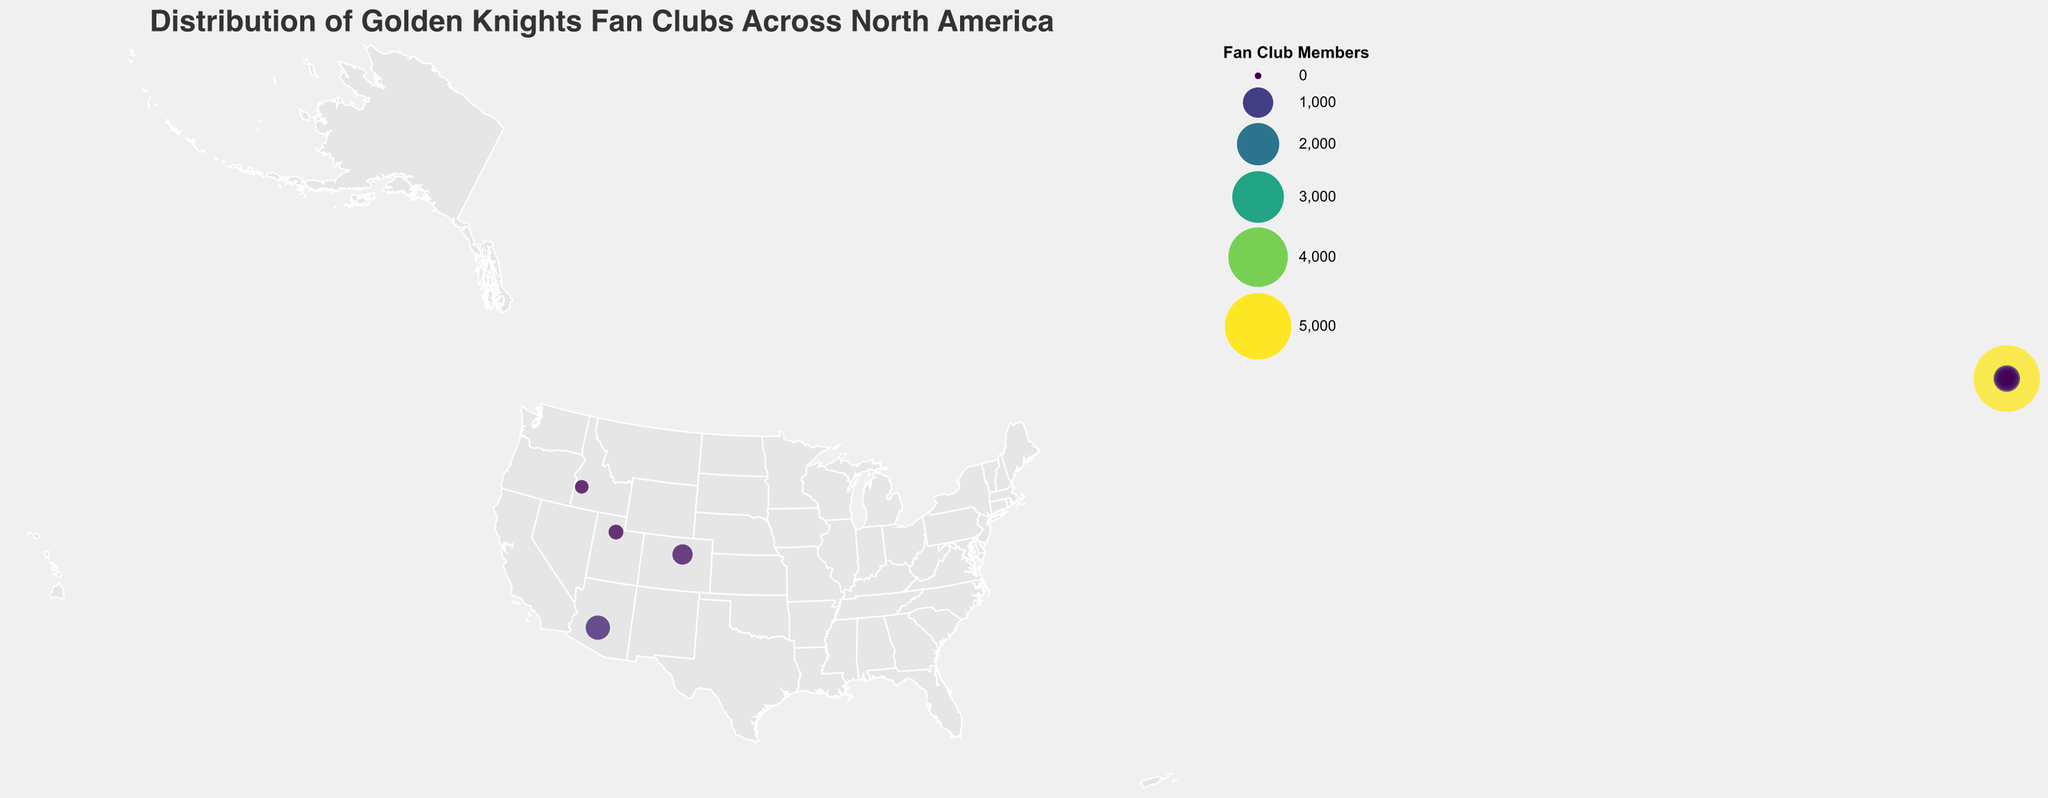Which city has the largest number of Golden Knights fan club members? The largest circle on the map represents the city with the highest number of fan club members, which is Las Vegas with 5000 members.
Answer: Las Vegas What is the total number of Golden Knights fan club members across all listed cities? Add the fan club members of all cities: 5000 + 750 + 620 + 580 + 510 + 480 + 450 + 420 + 390 + 350 + 320 + 300 + 280 + 260 + 240 + 220 + 200 + 180 + 160 + 140 = 12250.
Answer: 12250 Which country has more cities with notable fan clubs, USA or Canada? Count the number of cities listed by country. USA has 14 cities while Canada has 6 cities.
Answer: USA How many fan club members are there in Canadian cities combined? Add the fan club members in all Canadian cities: 510 (Vancouver) + 480 (Calgary) + 450 (Toronto) + 300 (Montreal) + 260 (Edmonton) + 220 (Winnipeg) = 2220.
Answer: 2220 Which city has the smallest fan club and how many members does it have? The smallest circle represents the city with the smallest fan club, which is Albuquerque with 140 members.
Answer: Albuquerque, 140 What is the average number of fan club members per city in the USA? Sum the fan club members for the USA cities and divide by the number of USA cities: (5000 + 750 + 620 + 580 + 420 + 390 + 350 + 320 + 280 + 240 + 200 + 180 + 160 + 140) / 14 = 10630 / 14 = 759.29.
Answer: 759.29 Which state in the USA has the second highest number of fan club members? Identify the total fan club members by state. California is the second highest with Los Angeles (750) and San Jose (280) totaling 1030 members.
Answer: California How do the fan club sizes compare between Las Vegas and New York City? Compare the number of fan club members in Las Vegas (5000) and New York City (320). Las Vegas has 4680 more members.
Answer: Las Vegas has 4680 more members What is the median number of fan club members across all cities? Sort the member counts and find the middle value: [140, 160, 180, 200, 220, 240, 260, 280, 300, 320, 350, 390, 420, 450, 480, 510, 580, 620, 750, 5000]. The median is the average of the 10th and 11th values, (320 + 350) / 2 = 335.
Answer: 335 How does the distribution of fan clubs in the USA compare to Canada in terms of geographic spread? Observing the map, the fan clubs in the USA are spread across a wider geographic area, covering more states and regions, while the Canadian fan clubs are mostly clustered in larger cities across the southern part of the country.
Answer: Broader geographic spread in the USA 